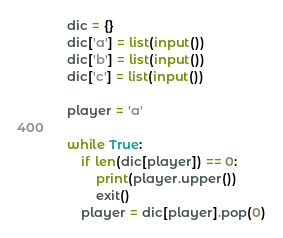Convert code to text. <code><loc_0><loc_0><loc_500><loc_500><_Python_>dic = {}
dic['a'] = list(input())
dic['b'] = list(input())
dic['c'] = list(input())

player = 'a'

while True:
    if len(dic[player]) == 0:
        print(player.upper())
        exit()
    player = dic[player].pop(0)</code> 